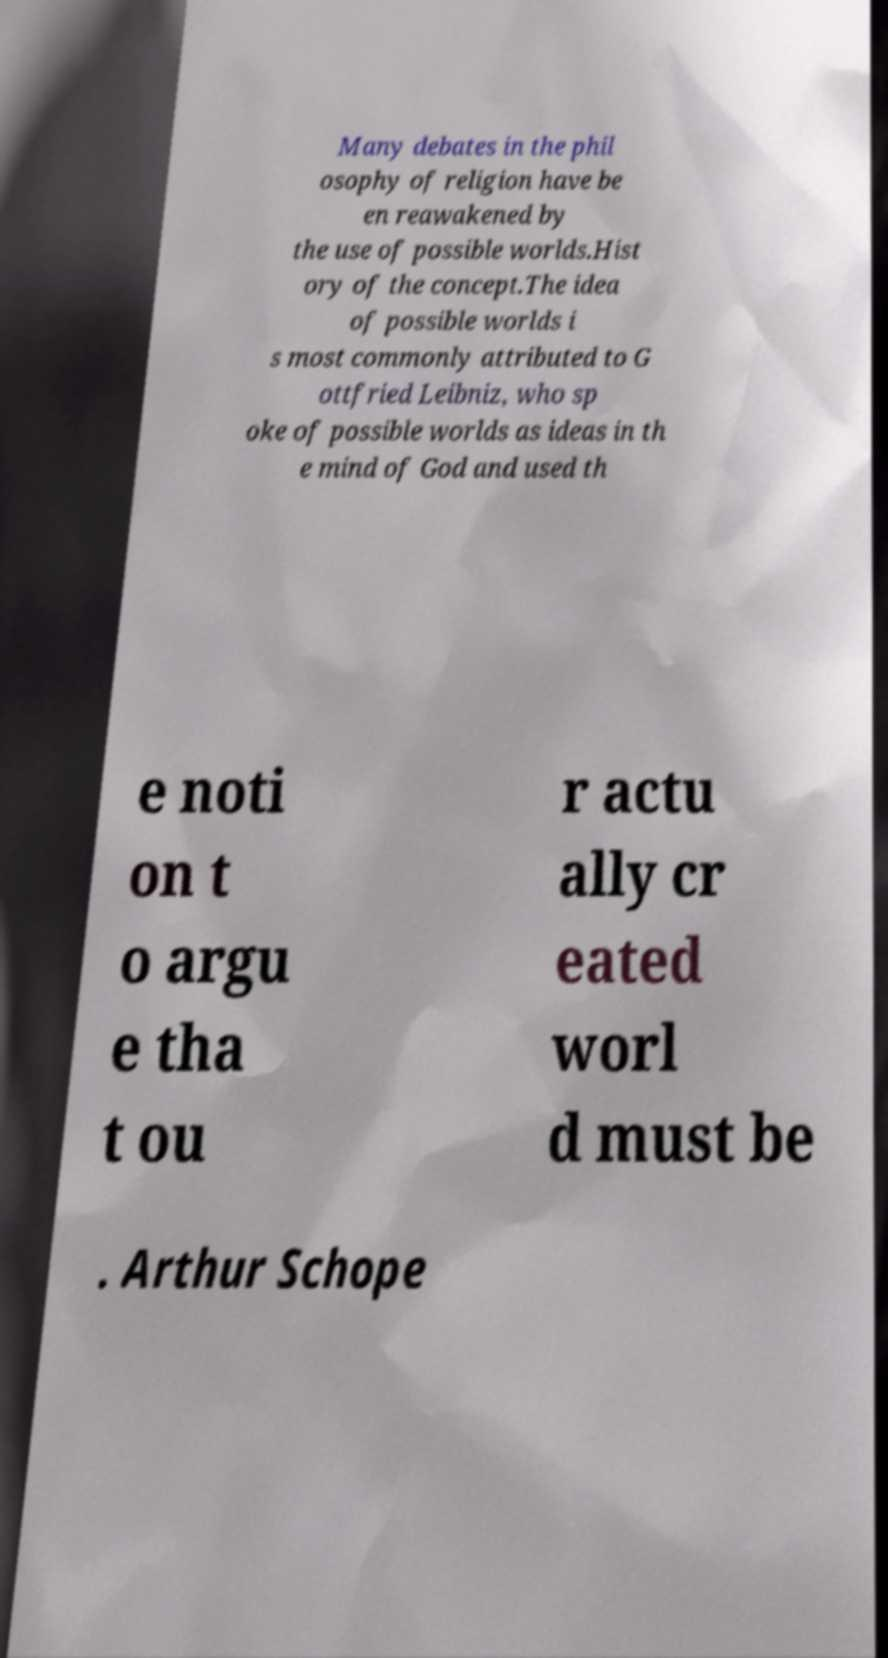There's text embedded in this image that I need extracted. Can you transcribe it verbatim? Many debates in the phil osophy of religion have be en reawakened by the use of possible worlds.Hist ory of the concept.The idea of possible worlds i s most commonly attributed to G ottfried Leibniz, who sp oke of possible worlds as ideas in th e mind of God and used th e noti on t o argu e tha t ou r actu ally cr eated worl d must be . Arthur Schope 